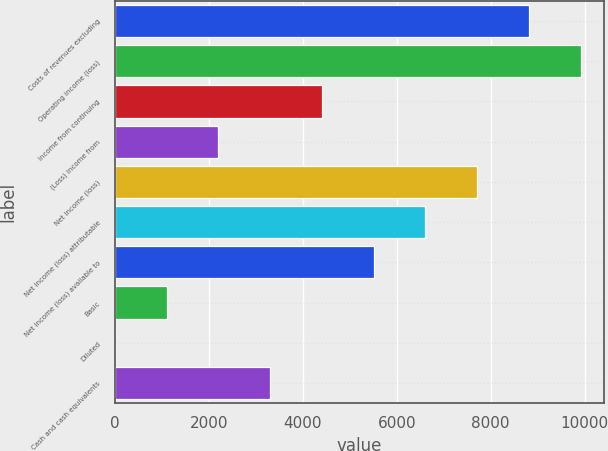Convert chart. <chart><loc_0><loc_0><loc_500><loc_500><bar_chart><fcel>Costs of revenues excluding<fcel>Operating income (loss)<fcel>Income from continuing<fcel>(Loss) income from<fcel>Net income (loss)<fcel>Net income (loss) attributable<fcel>Net income (loss) available to<fcel>Basic<fcel>Diluted<fcel>Cash and cash equivalents<nl><fcel>8815.47<fcel>9917.22<fcel>4408.47<fcel>2204.97<fcel>7713.72<fcel>6611.97<fcel>5510.22<fcel>1103.22<fcel>1.47<fcel>3306.72<nl></chart> 